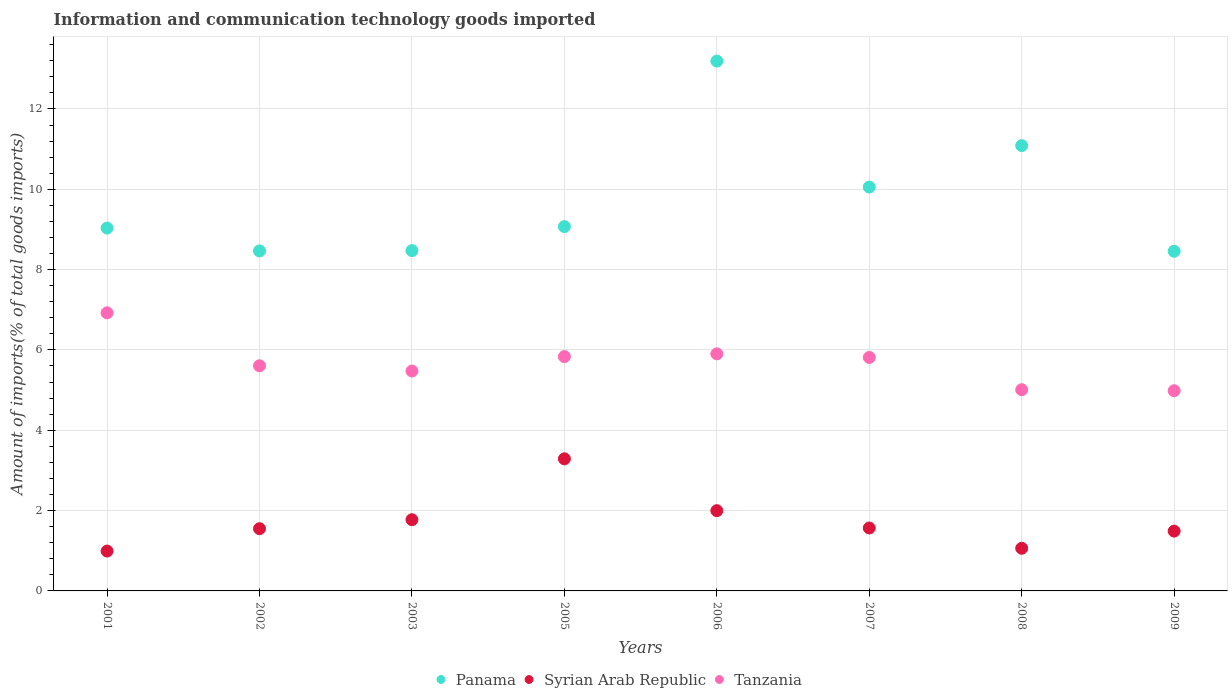How many different coloured dotlines are there?
Keep it short and to the point. 3. What is the amount of goods imported in Tanzania in 2002?
Provide a short and direct response. 5.6. Across all years, what is the maximum amount of goods imported in Syrian Arab Republic?
Offer a terse response. 3.29. Across all years, what is the minimum amount of goods imported in Panama?
Give a very brief answer. 8.46. In which year was the amount of goods imported in Tanzania minimum?
Ensure brevity in your answer.  2009. What is the total amount of goods imported in Tanzania in the graph?
Provide a succinct answer. 45.55. What is the difference between the amount of goods imported in Syrian Arab Republic in 2002 and that in 2006?
Offer a very short reply. -0.45. What is the difference between the amount of goods imported in Panama in 2001 and the amount of goods imported in Tanzania in 2008?
Your answer should be very brief. 4.02. What is the average amount of goods imported in Panama per year?
Make the answer very short. 9.73. In the year 2005, what is the difference between the amount of goods imported in Tanzania and amount of goods imported in Panama?
Your response must be concise. -3.24. What is the ratio of the amount of goods imported in Tanzania in 2003 to that in 2006?
Your answer should be very brief. 0.93. Is the amount of goods imported in Syrian Arab Republic in 2001 less than that in 2007?
Your response must be concise. Yes. Is the difference between the amount of goods imported in Tanzania in 2001 and 2006 greater than the difference between the amount of goods imported in Panama in 2001 and 2006?
Ensure brevity in your answer.  Yes. What is the difference between the highest and the second highest amount of goods imported in Panama?
Make the answer very short. 2.11. What is the difference between the highest and the lowest amount of goods imported in Syrian Arab Republic?
Ensure brevity in your answer.  2.3. In how many years, is the amount of goods imported in Panama greater than the average amount of goods imported in Panama taken over all years?
Provide a short and direct response. 3. Is the sum of the amount of goods imported in Tanzania in 2002 and 2008 greater than the maximum amount of goods imported in Syrian Arab Republic across all years?
Provide a succinct answer. Yes. Is it the case that in every year, the sum of the amount of goods imported in Syrian Arab Republic and amount of goods imported in Tanzania  is greater than the amount of goods imported in Panama?
Your response must be concise. No. Is the amount of goods imported in Tanzania strictly greater than the amount of goods imported in Panama over the years?
Provide a short and direct response. No. How many years are there in the graph?
Provide a succinct answer. 8. What is the difference between two consecutive major ticks on the Y-axis?
Provide a short and direct response. 2. Does the graph contain grids?
Offer a very short reply. Yes. How many legend labels are there?
Give a very brief answer. 3. How are the legend labels stacked?
Make the answer very short. Horizontal. What is the title of the graph?
Offer a terse response. Information and communication technology goods imported. Does "Marshall Islands" appear as one of the legend labels in the graph?
Provide a short and direct response. No. What is the label or title of the Y-axis?
Give a very brief answer. Amount of imports(% of total goods imports). What is the Amount of imports(% of total goods imports) of Panama in 2001?
Make the answer very short. 9.03. What is the Amount of imports(% of total goods imports) in Syrian Arab Republic in 2001?
Your answer should be very brief. 0.99. What is the Amount of imports(% of total goods imports) in Tanzania in 2001?
Your answer should be compact. 6.92. What is the Amount of imports(% of total goods imports) in Panama in 2002?
Provide a succinct answer. 8.46. What is the Amount of imports(% of total goods imports) in Syrian Arab Republic in 2002?
Give a very brief answer. 1.55. What is the Amount of imports(% of total goods imports) of Tanzania in 2002?
Offer a terse response. 5.6. What is the Amount of imports(% of total goods imports) of Panama in 2003?
Ensure brevity in your answer.  8.47. What is the Amount of imports(% of total goods imports) in Syrian Arab Republic in 2003?
Ensure brevity in your answer.  1.77. What is the Amount of imports(% of total goods imports) of Tanzania in 2003?
Your answer should be compact. 5.47. What is the Amount of imports(% of total goods imports) of Panama in 2005?
Your answer should be compact. 9.07. What is the Amount of imports(% of total goods imports) of Syrian Arab Republic in 2005?
Give a very brief answer. 3.29. What is the Amount of imports(% of total goods imports) of Tanzania in 2005?
Provide a succinct answer. 5.83. What is the Amount of imports(% of total goods imports) in Panama in 2006?
Ensure brevity in your answer.  13.19. What is the Amount of imports(% of total goods imports) in Syrian Arab Republic in 2006?
Keep it short and to the point. 2. What is the Amount of imports(% of total goods imports) in Tanzania in 2006?
Your answer should be compact. 5.9. What is the Amount of imports(% of total goods imports) of Panama in 2007?
Offer a terse response. 10.06. What is the Amount of imports(% of total goods imports) in Syrian Arab Republic in 2007?
Provide a succinct answer. 1.57. What is the Amount of imports(% of total goods imports) in Tanzania in 2007?
Keep it short and to the point. 5.81. What is the Amount of imports(% of total goods imports) of Panama in 2008?
Your answer should be very brief. 11.09. What is the Amount of imports(% of total goods imports) in Syrian Arab Republic in 2008?
Give a very brief answer. 1.06. What is the Amount of imports(% of total goods imports) in Tanzania in 2008?
Ensure brevity in your answer.  5.01. What is the Amount of imports(% of total goods imports) in Panama in 2009?
Provide a succinct answer. 8.46. What is the Amount of imports(% of total goods imports) in Syrian Arab Republic in 2009?
Give a very brief answer. 1.49. What is the Amount of imports(% of total goods imports) in Tanzania in 2009?
Give a very brief answer. 4.98. Across all years, what is the maximum Amount of imports(% of total goods imports) of Panama?
Make the answer very short. 13.19. Across all years, what is the maximum Amount of imports(% of total goods imports) of Syrian Arab Republic?
Your response must be concise. 3.29. Across all years, what is the maximum Amount of imports(% of total goods imports) in Tanzania?
Ensure brevity in your answer.  6.92. Across all years, what is the minimum Amount of imports(% of total goods imports) of Panama?
Provide a succinct answer. 8.46. Across all years, what is the minimum Amount of imports(% of total goods imports) of Syrian Arab Republic?
Your answer should be very brief. 0.99. Across all years, what is the minimum Amount of imports(% of total goods imports) of Tanzania?
Your answer should be very brief. 4.98. What is the total Amount of imports(% of total goods imports) of Panama in the graph?
Your response must be concise. 77.83. What is the total Amount of imports(% of total goods imports) in Syrian Arab Republic in the graph?
Give a very brief answer. 13.72. What is the total Amount of imports(% of total goods imports) of Tanzania in the graph?
Offer a terse response. 45.55. What is the difference between the Amount of imports(% of total goods imports) of Panama in 2001 and that in 2002?
Your answer should be very brief. 0.57. What is the difference between the Amount of imports(% of total goods imports) of Syrian Arab Republic in 2001 and that in 2002?
Ensure brevity in your answer.  -0.56. What is the difference between the Amount of imports(% of total goods imports) in Tanzania in 2001 and that in 2002?
Offer a very short reply. 1.32. What is the difference between the Amount of imports(% of total goods imports) of Panama in 2001 and that in 2003?
Your answer should be compact. 0.56. What is the difference between the Amount of imports(% of total goods imports) of Syrian Arab Republic in 2001 and that in 2003?
Keep it short and to the point. -0.78. What is the difference between the Amount of imports(% of total goods imports) of Tanzania in 2001 and that in 2003?
Ensure brevity in your answer.  1.45. What is the difference between the Amount of imports(% of total goods imports) in Panama in 2001 and that in 2005?
Provide a short and direct response. -0.04. What is the difference between the Amount of imports(% of total goods imports) of Syrian Arab Republic in 2001 and that in 2005?
Ensure brevity in your answer.  -2.3. What is the difference between the Amount of imports(% of total goods imports) of Tanzania in 2001 and that in 2005?
Your answer should be very brief. 1.09. What is the difference between the Amount of imports(% of total goods imports) in Panama in 2001 and that in 2006?
Offer a terse response. -4.16. What is the difference between the Amount of imports(% of total goods imports) in Syrian Arab Republic in 2001 and that in 2006?
Your response must be concise. -1.01. What is the difference between the Amount of imports(% of total goods imports) in Tanzania in 2001 and that in 2006?
Your answer should be very brief. 1.02. What is the difference between the Amount of imports(% of total goods imports) in Panama in 2001 and that in 2007?
Ensure brevity in your answer.  -1.02. What is the difference between the Amount of imports(% of total goods imports) of Syrian Arab Republic in 2001 and that in 2007?
Keep it short and to the point. -0.57. What is the difference between the Amount of imports(% of total goods imports) of Tanzania in 2001 and that in 2007?
Your answer should be very brief. 1.11. What is the difference between the Amount of imports(% of total goods imports) of Panama in 2001 and that in 2008?
Your response must be concise. -2.05. What is the difference between the Amount of imports(% of total goods imports) of Syrian Arab Republic in 2001 and that in 2008?
Make the answer very short. -0.07. What is the difference between the Amount of imports(% of total goods imports) in Tanzania in 2001 and that in 2008?
Your answer should be compact. 1.91. What is the difference between the Amount of imports(% of total goods imports) in Panama in 2001 and that in 2009?
Give a very brief answer. 0.58. What is the difference between the Amount of imports(% of total goods imports) in Syrian Arab Republic in 2001 and that in 2009?
Your answer should be very brief. -0.5. What is the difference between the Amount of imports(% of total goods imports) of Tanzania in 2001 and that in 2009?
Provide a short and direct response. 1.94. What is the difference between the Amount of imports(% of total goods imports) in Panama in 2002 and that in 2003?
Offer a terse response. -0.01. What is the difference between the Amount of imports(% of total goods imports) in Syrian Arab Republic in 2002 and that in 2003?
Ensure brevity in your answer.  -0.22. What is the difference between the Amount of imports(% of total goods imports) in Tanzania in 2002 and that in 2003?
Offer a very short reply. 0.13. What is the difference between the Amount of imports(% of total goods imports) of Panama in 2002 and that in 2005?
Give a very brief answer. -0.61. What is the difference between the Amount of imports(% of total goods imports) of Syrian Arab Republic in 2002 and that in 2005?
Give a very brief answer. -1.74. What is the difference between the Amount of imports(% of total goods imports) of Tanzania in 2002 and that in 2005?
Provide a short and direct response. -0.23. What is the difference between the Amount of imports(% of total goods imports) in Panama in 2002 and that in 2006?
Provide a short and direct response. -4.73. What is the difference between the Amount of imports(% of total goods imports) of Syrian Arab Republic in 2002 and that in 2006?
Provide a short and direct response. -0.45. What is the difference between the Amount of imports(% of total goods imports) in Tanzania in 2002 and that in 2006?
Ensure brevity in your answer.  -0.3. What is the difference between the Amount of imports(% of total goods imports) in Panama in 2002 and that in 2007?
Offer a very short reply. -1.59. What is the difference between the Amount of imports(% of total goods imports) in Syrian Arab Republic in 2002 and that in 2007?
Provide a short and direct response. -0.02. What is the difference between the Amount of imports(% of total goods imports) of Tanzania in 2002 and that in 2007?
Give a very brief answer. -0.21. What is the difference between the Amount of imports(% of total goods imports) of Panama in 2002 and that in 2008?
Keep it short and to the point. -2.62. What is the difference between the Amount of imports(% of total goods imports) in Syrian Arab Republic in 2002 and that in 2008?
Ensure brevity in your answer.  0.49. What is the difference between the Amount of imports(% of total goods imports) of Tanzania in 2002 and that in 2008?
Keep it short and to the point. 0.6. What is the difference between the Amount of imports(% of total goods imports) in Panama in 2002 and that in 2009?
Make the answer very short. 0.01. What is the difference between the Amount of imports(% of total goods imports) of Syrian Arab Republic in 2002 and that in 2009?
Offer a terse response. 0.06. What is the difference between the Amount of imports(% of total goods imports) of Tanzania in 2002 and that in 2009?
Offer a very short reply. 0.62. What is the difference between the Amount of imports(% of total goods imports) in Panama in 2003 and that in 2005?
Your response must be concise. -0.6. What is the difference between the Amount of imports(% of total goods imports) in Syrian Arab Republic in 2003 and that in 2005?
Your answer should be compact. -1.52. What is the difference between the Amount of imports(% of total goods imports) of Tanzania in 2003 and that in 2005?
Give a very brief answer. -0.36. What is the difference between the Amount of imports(% of total goods imports) of Panama in 2003 and that in 2006?
Your response must be concise. -4.72. What is the difference between the Amount of imports(% of total goods imports) of Syrian Arab Republic in 2003 and that in 2006?
Ensure brevity in your answer.  -0.22. What is the difference between the Amount of imports(% of total goods imports) in Tanzania in 2003 and that in 2006?
Provide a short and direct response. -0.43. What is the difference between the Amount of imports(% of total goods imports) of Panama in 2003 and that in 2007?
Your answer should be compact. -1.58. What is the difference between the Amount of imports(% of total goods imports) of Syrian Arab Republic in 2003 and that in 2007?
Your answer should be compact. 0.21. What is the difference between the Amount of imports(% of total goods imports) in Tanzania in 2003 and that in 2007?
Give a very brief answer. -0.34. What is the difference between the Amount of imports(% of total goods imports) in Panama in 2003 and that in 2008?
Your answer should be compact. -2.61. What is the difference between the Amount of imports(% of total goods imports) of Syrian Arab Republic in 2003 and that in 2008?
Give a very brief answer. 0.71. What is the difference between the Amount of imports(% of total goods imports) of Tanzania in 2003 and that in 2008?
Offer a very short reply. 0.47. What is the difference between the Amount of imports(% of total goods imports) of Panama in 2003 and that in 2009?
Ensure brevity in your answer.  0.02. What is the difference between the Amount of imports(% of total goods imports) in Syrian Arab Republic in 2003 and that in 2009?
Keep it short and to the point. 0.28. What is the difference between the Amount of imports(% of total goods imports) in Tanzania in 2003 and that in 2009?
Make the answer very short. 0.49. What is the difference between the Amount of imports(% of total goods imports) in Panama in 2005 and that in 2006?
Your answer should be very brief. -4.12. What is the difference between the Amount of imports(% of total goods imports) in Syrian Arab Republic in 2005 and that in 2006?
Offer a terse response. 1.29. What is the difference between the Amount of imports(% of total goods imports) in Tanzania in 2005 and that in 2006?
Provide a short and direct response. -0.07. What is the difference between the Amount of imports(% of total goods imports) in Panama in 2005 and that in 2007?
Offer a terse response. -0.98. What is the difference between the Amount of imports(% of total goods imports) of Syrian Arab Republic in 2005 and that in 2007?
Provide a short and direct response. 1.72. What is the difference between the Amount of imports(% of total goods imports) of Tanzania in 2005 and that in 2007?
Make the answer very short. 0.02. What is the difference between the Amount of imports(% of total goods imports) of Panama in 2005 and that in 2008?
Offer a very short reply. -2.02. What is the difference between the Amount of imports(% of total goods imports) of Syrian Arab Republic in 2005 and that in 2008?
Keep it short and to the point. 2.23. What is the difference between the Amount of imports(% of total goods imports) of Tanzania in 2005 and that in 2008?
Ensure brevity in your answer.  0.82. What is the difference between the Amount of imports(% of total goods imports) in Panama in 2005 and that in 2009?
Your answer should be very brief. 0.61. What is the difference between the Amount of imports(% of total goods imports) in Syrian Arab Republic in 2005 and that in 2009?
Offer a very short reply. 1.8. What is the difference between the Amount of imports(% of total goods imports) in Tanzania in 2005 and that in 2009?
Your answer should be very brief. 0.85. What is the difference between the Amount of imports(% of total goods imports) in Panama in 2006 and that in 2007?
Your answer should be very brief. 3.14. What is the difference between the Amount of imports(% of total goods imports) of Syrian Arab Republic in 2006 and that in 2007?
Your answer should be compact. 0.43. What is the difference between the Amount of imports(% of total goods imports) in Tanzania in 2006 and that in 2007?
Make the answer very short. 0.09. What is the difference between the Amount of imports(% of total goods imports) of Panama in 2006 and that in 2008?
Provide a succinct answer. 2.1. What is the difference between the Amount of imports(% of total goods imports) of Syrian Arab Republic in 2006 and that in 2008?
Your answer should be very brief. 0.94. What is the difference between the Amount of imports(% of total goods imports) in Tanzania in 2006 and that in 2008?
Your answer should be very brief. 0.89. What is the difference between the Amount of imports(% of total goods imports) in Panama in 2006 and that in 2009?
Make the answer very short. 4.74. What is the difference between the Amount of imports(% of total goods imports) in Syrian Arab Republic in 2006 and that in 2009?
Give a very brief answer. 0.51. What is the difference between the Amount of imports(% of total goods imports) of Tanzania in 2006 and that in 2009?
Provide a short and direct response. 0.92. What is the difference between the Amount of imports(% of total goods imports) in Panama in 2007 and that in 2008?
Provide a succinct answer. -1.03. What is the difference between the Amount of imports(% of total goods imports) in Syrian Arab Republic in 2007 and that in 2008?
Your answer should be very brief. 0.5. What is the difference between the Amount of imports(% of total goods imports) in Tanzania in 2007 and that in 2008?
Your answer should be compact. 0.8. What is the difference between the Amount of imports(% of total goods imports) of Panama in 2007 and that in 2009?
Your answer should be very brief. 1.6. What is the difference between the Amount of imports(% of total goods imports) in Syrian Arab Republic in 2007 and that in 2009?
Offer a terse response. 0.08. What is the difference between the Amount of imports(% of total goods imports) in Tanzania in 2007 and that in 2009?
Ensure brevity in your answer.  0.83. What is the difference between the Amount of imports(% of total goods imports) of Panama in 2008 and that in 2009?
Provide a succinct answer. 2.63. What is the difference between the Amount of imports(% of total goods imports) in Syrian Arab Republic in 2008 and that in 2009?
Provide a succinct answer. -0.43. What is the difference between the Amount of imports(% of total goods imports) of Tanzania in 2008 and that in 2009?
Make the answer very short. 0.03. What is the difference between the Amount of imports(% of total goods imports) of Panama in 2001 and the Amount of imports(% of total goods imports) of Syrian Arab Republic in 2002?
Make the answer very short. 7.48. What is the difference between the Amount of imports(% of total goods imports) in Panama in 2001 and the Amount of imports(% of total goods imports) in Tanzania in 2002?
Ensure brevity in your answer.  3.43. What is the difference between the Amount of imports(% of total goods imports) in Syrian Arab Republic in 2001 and the Amount of imports(% of total goods imports) in Tanzania in 2002?
Offer a very short reply. -4.61. What is the difference between the Amount of imports(% of total goods imports) of Panama in 2001 and the Amount of imports(% of total goods imports) of Syrian Arab Republic in 2003?
Provide a succinct answer. 7.26. What is the difference between the Amount of imports(% of total goods imports) of Panama in 2001 and the Amount of imports(% of total goods imports) of Tanzania in 2003?
Offer a terse response. 3.56. What is the difference between the Amount of imports(% of total goods imports) in Syrian Arab Republic in 2001 and the Amount of imports(% of total goods imports) in Tanzania in 2003?
Your answer should be very brief. -4.48. What is the difference between the Amount of imports(% of total goods imports) in Panama in 2001 and the Amount of imports(% of total goods imports) in Syrian Arab Republic in 2005?
Provide a succinct answer. 5.74. What is the difference between the Amount of imports(% of total goods imports) of Panama in 2001 and the Amount of imports(% of total goods imports) of Tanzania in 2005?
Your answer should be compact. 3.2. What is the difference between the Amount of imports(% of total goods imports) in Syrian Arab Republic in 2001 and the Amount of imports(% of total goods imports) in Tanzania in 2005?
Provide a short and direct response. -4.84. What is the difference between the Amount of imports(% of total goods imports) in Panama in 2001 and the Amount of imports(% of total goods imports) in Syrian Arab Republic in 2006?
Provide a succinct answer. 7.04. What is the difference between the Amount of imports(% of total goods imports) in Panama in 2001 and the Amount of imports(% of total goods imports) in Tanzania in 2006?
Offer a terse response. 3.13. What is the difference between the Amount of imports(% of total goods imports) of Syrian Arab Republic in 2001 and the Amount of imports(% of total goods imports) of Tanzania in 2006?
Offer a terse response. -4.91. What is the difference between the Amount of imports(% of total goods imports) of Panama in 2001 and the Amount of imports(% of total goods imports) of Syrian Arab Republic in 2007?
Your answer should be very brief. 7.47. What is the difference between the Amount of imports(% of total goods imports) of Panama in 2001 and the Amount of imports(% of total goods imports) of Tanzania in 2007?
Ensure brevity in your answer.  3.22. What is the difference between the Amount of imports(% of total goods imports) of Syrian Arab Republic in 2001 and the Amount of imports(% of total goods imports) of Tanzania in 2007?
Offer a very short reply. -4.82. What is the difference between the Amount of imports(% of total goods imports) in Panama in 2001 and the Amount of imports(% of total goods imports) in Syrian Arab Republic in 2008?
Offer a terse response. 7.97. What is the difference between the Amount of imports(% of total goods imports) of Panama in 2001 and the Amount of imports(% of total goods imports) of Tanzania in 2008?
Provide a succinct answer. 4.02. What is the difference between the Amount of imports(% of total goods imports) of Syrian Arab Republic in 2001 and the Amount of imports(% of total goods imports) of Tanzania in 2008?
Your answer should be compact. -4.02. What is the difference between the Amount of imports(% of total goods imports) of Panama in 2001 and the Amount of imports(% of total goods imports) of Syrian Arab Republic in 2009?
Provide a succinct answer. 7.54. What is the difference between the Amount of imports(% of total goods imports) in Panama in 2001 and the Amount of imports(% of total goods imports) in Tanzania in 2009?
Keep it short and to the point. 4.05. What is the difference between the Amount of imports(% of total goods imports) of Syrian Arab Republic in 2001 and the Amount of imports(% of total goods imports) of Tanzania in 2009?
Your answer should be very brief. -3.99. What is the difference between the Amount of imports(% of total goods imports) in Panama in 2002 and the Amount of imports(% of total goods imports) in Syrian Arab Republic in 2003?
Offer a terse response. 6.69. What is the difference between the Amount of imports(% of total goods imports) of Panama in 2002 and the Amount of imports(% of total goods imports) of Tanzania in 2003?
Provide a short and direct response. 2.99. What is the difference between the Amount of imports(% of total goods imports) in Syrian Arab Republic in 2002 and the Amount of imports(% of total goods imports) in Tanzania in 2003?
Offer a terse response. -3.93. What is the difference between the Amount of imports(% of total goods imports) of Panama in 2002 and the Amount of imports(% of total goods imports) of Syrian Arab Republic in 2005?
Keep it short and to the point. 5.18. What is the difference between the Amount of imports(% of total goods imports) in Panama in 2002 and the Amount of imports(% of total goods imports) in Tanzania in 2005?
Your response must be concise. 2.63. What is the difference between the Amount of imports(% of total goods imports) in Syrian Arab Republic in 2002 and the Amount of imports(% of total goods imports) in Tanzania in 2005?
Offer a terse response. -4.28. What is the difference between the Amount of imports(% of total goods imports) in Panama in 2002 and the Amount of imports(% of total goods imports) in Syrian Arab Republic in 2006?
Provide a succinct answer. 6.47. What is the difference between the Amount of imports(% of total goods imports) of Panama in 2002 and the Amount of imports(% of total goods imports) of Tanzania in 2006?
Provide a short and direct response. 2.56. What is the difference between the Amount of imports(% of total goods imports) in Syrian Arab Republic in 2002 and the Amount of imports(% of total goods imports) in Tanzania in 2006?
Provide a succinct answer. -4.35. What is the difference between the Amount of imports(% of total goods imports) of Panama in 2002 and the Amount of imports(% of total goods imports) of Syrian Arab Republic in 2007?
Your answer should be compact. 6.9. What is the difference between the Amount of imports(% of total goods imports) in Panama in 2002 and the Amount of imports(% of total goods imports) in Tanzania in 2007?
Offer a very short reply. 2.65. What is the difference between the Amount of imports(% of total goods imports) in Syrian Arab Republic in 2002 and the Amount of imports(% of total goods imports) in Tanzania in 2007?
Provide a succinct answer. -4.26. What is the difference between the Amount of imports(% of total goods imports) in Panama in 2002 and the Amount of imports(% of total goods imports) in Syrian Arab Republic in 2008?
Offer a very short reply. 7.4. What is the difference between the Amount of imports(% of total goods imports) of Panama in 2002 and the Amount of imports(% of total goods imports) of Tanzania in 2008?
Provide a short and direct response. 3.45. What is the difference between the Amount of imports(% of total goods imports) in Syrian Arab Republic in 2002 and the Amount of imports(% of total goods imports) in Tanzania in 2008?
Ensure brevity in your answer.  -3.46. What is the difference between the Amount of imports(% of total goods imports) of Panama in 2002 and the Amount of imports(% of total goods imports) of Syrian Arab Republic in 2009?
Ensure brevity in your answer.  6.98. What is the difference between the Amount of imports(% of total goods imports) in Panama in 2002 and the Amount of imports(% of total goods imports) in Tanzania in 2009?
Your answer should be very brief. 3.48. What is the difference between the Amount of imports(% of total goods imports) in Syrian Arab Republic in 2002 and the Amount of imports(% of total goods imports) in Tanzania in 2009?
Make the answer very short. -3.43. What is the difference between the Amount of imports(% of total goods imports) of Panama in 2003 and the Amount of imports(% of total goods imports) of Syrian Arab Republic in 2005?
Provide a succinct answer. 5.18. What is the difference between the Amount of imports(% of total goods imports) in Panama in 2003 and the Amount of imports(% of total goods imports) in Tanzania in 2005?
Ensure brevity in your answer.  2.64. What is the difference between the Amount of imports(% of total goods imports) of Syrian Arab Republic in 2003 and the Amount of imports(% of total goods imports) of Tanzania in 2005?
Your answer should be compact. -4.06. What is the difference between the Amount of imports(% of total goods imports) in Panama in 2003 and the Amount of imports(% of total goods imports) in Syrian Arab Republic in 2006?
Give a very brief answer. 6.47. What is the difference between the Amount of imports(% of total goods imports) of Panama in 2003 and the Amount of imports(% of total goods imports) of Tanzania in 2006?
Keep it short and to the point. 2.57. What is the difference between the Amount of imports(% of total goods imports) of Syrian Arab Republic in 2003 and the Amount of imports(% of total goods imports) of Tanzania in 2006?
Ensure brevity in your answer.  -4.13. What is the difference between the Amount of imports(% of total goods imports) in Panama in 2003 and the Amount of imports(% of total goods imports) in Syrian Arab Republic in 2007?
Keep it short and to the point. 6.91. What is the difference between the Amount of imports(% of total goods imports) in Panama in 2003 and the Amount of imports(% of total goods imports) in Tanzania in 2007?
Keep it short and to the point. 2.66. What is the difference between the Amount of imports(% of total goods imports) in Syrian Arab Republic in 2003 and the Amount of imports(% of total goods imports) in Tanzania in 2007?
Your answer should be compact. -4.04. What is the difference between the Amount of imports(% of total goods imports) of Panama in 2003 and the Amount of imports(% of total goods imports) of Syrian Arab Republic in 2008?
Keep it short and to the point. 7.41. What is the difference between the Amount of imports(% of total goods imports) of Panama in 2003 and the Amount of imports(% of total goods imports) of Tanzania in 2008?
Ensure brevity in your answer.  3.46. What is the difference between the Amount of imports(% of total goods imports) of Syrian Arab Republic in 2003 and the Amount of imports(% of total goods imports) of Tanzania in 2008?
Ensure brevity in your answer.  -3.24. What is the difference between the Amount of imports(% of total goods imports) in Panama in 2003 and the Amount of imports(% of total goods imports) in Syrian Arab Republic in 2009?
Give a very brief answer. 6.98. What is the difference between the Amount of imports(% of total goods imports) of Panama in 2003 and the Amount of imports(% of total goods imports) of Tanzania in 2009?
Ensure brevity in your answer.  3.49. What is the difference between the Amount of imports(% of total goods imports) of Syrian Arab Republic in 2003 and the Amount of imports(% of total goods imports) of Tanzania in 2009?
Give a very brief answer. -3.21. What is the difference between the Amount of imports(% of total goods imports) in Panama in 2005 and the Amount of imports(% of total goods imports) in Syrian Arab Republic in 2006?
Offer a very short reply. 7.07. What is the difference between the Amount of imports(% of total goods imports) in Panama in 2005 and the Amount of imports(% of total goods imports) in Tanzania in 2006?
Offer a terse response. 3.17. What is the difference between the Amount of imports(% of total goods imports) in Syrian Arab Republic in 2005 and the Amount of imports(% of total goods imports) in Tanzania in 2006?
Offer a very short reply. -2.61. What is the difference between the Amount of imports(% of total goods imports) of Panama in 2005 and the Amount of imports(% of total goods imports) of Syrian Arab Republic in 2007?
Make the answer very short. 7.5. What is the difference between the Amount of imports(% of total goods imports) of Panama in 2005 and the Amount of imports(% of total goods imports) of Tanzania in 2007?
Offer a very short reply. 3.26. What is the difference between the Amount of imports(% of total goods imports) in Syrian Arab Republic in 2005 and the Amount of imports(% of total goods imports) in Tanzania in 2007?
Offer a terse response. -2.52. What is the difference between the Amount of imports(% of total goods imports) in Panama in 2005 and the Amount of imports(% of total goods imports) in Syrian Arab Republic in 2008?
Your response must be concise. 8.01. What is the difference between the Amount of imports(% of total goods imports) in Panama in 2005 and the Amount of imports(% of total goods imports) in Tanzania in 2008?
Make the answer very short. 4.06. What is the difference between the Amount of imports(% of total goods imports) of Syrian Arab Republic in 2005 and the Amount of imports(% of total goods imports) of Tanzania in 2008?
Offer a terse response. -1.72. What is the difference between the Amount of imports(% of total goods imports) of Panama in 2005 and the Amount of imports(% of total goods imports) of Syrian Arab Republic in 2009?
Offer a very short reply. 7.58. What is the difference between the Amount of imports(% of total goods imports) in Panama in 2005 and the Amount of imports(% of total goods imports) in Tanzania in 2009?
Your response must be concise. 4.09. What is the difference between the Amount of imports(% of total goods imports) of Syrian Arab Republic in 2005 and the Amount of imports(% of total goods imports) of Tanzania in 2009?
Keep it short and to the point. -1.7. What is the difference between the Amount of imports(% of total goods imports) of Panama in 2006 and the Amount of imports(% of total goods imports) of Syrian Arab Republic in 2007?
Ensure brevity in your answer.  11.62. What is the difference between the Amount of imports(% of total goods imports) of Panama in 2006 and the Amount of imports(% of total goods imports) of Tanzania in 2007?
Offer a terse response. 7.38. What is the difference between the Amount of imports(% of total goods imports) of Syrian Arab Republic in 2006 and the Amount of imports(% of total goods imports) of Tanzania in 2007?
Ensure brevity in your answer.  -3.82. What is the difference between the Amount of imports(% of total goods imports) of Panama in 2006 and the Amount of imports(% of total goods imports) of Syrian Arab Republic in 2008?
Give a very brief answer. 12.13. What is the difference between the Amount of imports(% of total goods imports) of Panama in 2006 and the Amount of imports(% of total goods imports) of Tanzania in 2008?
Offer a terse response. 8.18. What is the difference between the Amount of imports(% of total goods imports) of Syrian Arab Republic in 2006 and the Amount of imports(% of total goods imports) of Tanzania in 2008?
Provide a short and direct response. -3.01. What is the difference between the Amount of imports(% of total goods imports) of Panama in 2006 and the Amount of imports(% of total goods imports) of Syrian Arab Republic in 2009?
Offer a terse response. 11.7. What is the difference between the Amount of imports(% of total goods imports) of Panama in 2006 and the Amount of imports(% of total goods imports) of Tanzania in 2009?
Offer a very short reply. 8.21. What is the difference between the Amount of imports(% of total goods imports) of Syrian Arab Republic in 2006 and the Amount of imports(% of total goods imports) of Tanzania in 2009?
Make the answer very short. -2.99. What is the difference between the Amount of imports(% of total goods imports) in Panama in 2007 and the Amount of imports(% of total goods imports) in Syrian Arab Republic in 2008?
Ensure brevity in your answer.  8.99. What is the difference between the Amount of imports(% of total goods imports) in Panama in 2007 and the Amount of imports(% of total goods imports) in Tanzania in 2008?
Make the answer very short. 5.05. What is the difference between the Amount of imports(% of total goods imports) in Syrian Arab Republic in 2007 and the Amount of imports(% of total goods imports) in Tanzania in 2008?
Keep it short and to the point. -3.44. What is the difference between the Amount of imports(% of total goods imports) in Panama in 2007 and the Amount of imports(% of total goods imports) in Syrian Arab Republic in 2009?
Your answer should be compact. 8.57. What is the difference between the Amount of imports(% of total goods imports) of Panama in 2007 and the Amount of imports(% of total goods imports) of Tanzania in 2009?
Offer a very short reply. 5.07. What is the difference between the Amount of imports(% of total goods imports) of Syrian Arab Republic in 2007 and the Amount of imports(% of total goods imports) of Tanzania in 2009?
Your answer should be very brief. -3.42. What is the difference between the Amount of imports(% of total goods imports) in Panama in 2008 and the Amount of imports(% of total goods imports) in Syrian Arab Republic in 2009?
Ensure brevity in your answer.  9.6. What is the difference between the Amount of imports(% of total goods imports) of Panama in 2008 and the Amount of imports(% of total goods imports) of Tanzania in 2009?
Keep it short and to the point. 6.1. What is the difference between the Amount of imports(% of total goods imports) in Syrian Arab Republic in 2008 and the Amount of imports(% of total goods imports) in Tanzania in 2009?
Your answer should be compact. -3.92. What is the average Amount of imports(% of total goods imports) of Panama per year?
Offer a terse response. 9.73. What is the average Amount of imports(% of total goods imports) in Syrian Arab Republic per year?
Keep it short and to the point. 1.72. What is the average Amount of imports(% of total goods imports) of Tanzania per year?
Your answer should be compact. 5.69. In the year 2001, what is the difference between the Amount of imports(% of total goods imports) of Panama and Amount of imports(% of total goods imports) of Syrian Arab Republic?
Make the answer very short. 8.04. In the year 2001, what is the difference between the Amount of imports(% of total goods imports) in Panama and Amount of imports(% of total goods imports) in Tanzania?
Ensure brevity in your answer.  2.11. In the year 2001, what is the difference between the Amount of imports(% of total goods imports) of Syrian Arab Republic and Amount of imports(% of total goods imports) of Tanzania?
Offer a terse response. -5.93. In the year 2002, what is the difference between the Amount of imports(% of total goods imports) of Panama and Amount of imports(% of total goods imports) of Syrian Arab Republic?
Provide a succinct answer. 6.91. In the year 2002, what is the difference between the Amount of imports(% of total goods imports) of Panama and Amount of imports(% of total goods imports) of Tanzania?
Offer a terse response. 2.86. In the year 2002, what is the difference between the Amount of imports(% of total goods imports) of Syrian Arab Republic and Amount of imports(% of total goods imports) of Tanzania?
Give a very brief answer. -4.05. In the year 2003, what is the difference between the Amount of imports(% of total goods imports) of Panama and Amount of imports(% of total goods imports) of Syrian Arab Republic?
Keep it short and to the point. 6.7. In the year 2003, what is the difference between the Amount of imports(% of total goods imports) in Panama and Amount of imports(% of total goods imports) in Tanzania?
Provide a succinct answer. 3. In the year 2003, what is the difference between the Amount of imports(% of total goods imports) in Syrian Arab Republic and Amount of imports(% of total goods imports) in Tanzania?
Provide a succinct answer. -3.7. In the year 2005, what is the difference between the Amount of imports(% of total goods imports) in Panama and Amount of imports(% of total goods imports) in Syrian Arab Republic?
Provide a short and direct response. 5.78. In the year 2005, what is the difference between the Amount of imports(% of total goods imports) of Panama and Amount of imports(% of total goods imports) of Tanzania?
Offer a terse response. 3.24. In the year 2005, what is the difference between the Amount of imports(% of total goods imports) of Syrian Arab Republic and Amount of imports(% of total goods imports) of Tanzania?
Keep it short and to the point. -2.54. In the year 2006, what is the difference between the Amount of imports(% of total goods imports) of Panama and Amount of imports(% of total goods imports) of Syrian Arab Republic?
Offer a very short reply. 11.19. In the year 2006, what is the difference between the Amount of imports(% of total goods imports) in Panama and Amount of imports(% of total goods imports) in Tanzania?
Your answer should be very brief. 7.29. In the year 2006, what is the difference between the Amount of imports(% of total goods imports) in Syrian Arab Republic and Amount of imports(% of total goods imports) in Tanzania?
Give a very brief answer. -3.9. In the year 2007, what is the difference between the Amount of imports(% of total goods imports) in Panama and Amount of imports(% of total goods imports) in Syrian Arab Republic?
Offer a terse response. 8.49. In the year 2007, what is the difference between the Amount of imports(% of total goods imports) of Panama and Amount of imports(% of total goods imports) of Tanzania?
Offer a terse response. 4.24. In the year 2007, what is the difference between the Amount of imports(% of total goods imports) of Syrian Arab Republic and Amount of imports(% of total goods imports) of Tanzania?
Your answer should be very brief. -4.25. In the year 2008, what is the difference between the Amount of imports(% of total goods imports) in Panama and Amount of imports(% of total goods imports) in Syrian Arab Republic?
Your answer should be very brief. 10.02. In the year 2008, what is the difference between the Amount of imports(% of total goods imports) in Panama and Amount of imports(% of total goods imports) in Tanzania?
Make the answer very short. 6.08. In the year 2008, what is the difference between the Amount of imports(% of total goods imports) of Syrian Arab Republic and Amount of imports(% of total goods imports) of Tanzania?
Your response must be concise. -3.95. In the year 2009, what is the difference between the Amount of imports(% of total goods imports) of Panama and Amount of imports(% of total goods imports) of Syrian Arab Republic?
Provide a short and direct response. 6.97. In the year 2009, what is the difference between the Amount of imports(% of total goods imports) in Panama and Amount of imports(% of total goods imports) in Tanzania?
Ensure brevity in your answer.  3.47. In the year 2009, what is the difference between the Amount of imports(% of total goods imports) in Syrian Arab Republic and Amount of imports(% of total goods imports) in Tanzania?
Ensure brevity in your answer.  -3.5. What is the ratio of the Amount of imports(% of total goods imports) of Panama in 2001 to that in 2002?
Give a very brief answer. 1.07. What is the ratio of the Amount of imports(% of total goods imports) of Syrian Arab Republic in 2001 to that in 2002?
Keep it short and to the point. 0.64. What is the ratio of the Amount of imports(% of total goods imports) of Tanzania in 2001 to that in 2002?
Provide a short and direct response. 1.24. What is the ratio of the Amount of imports(% of total goods imports) in Panama in 2001 to that in 2003?
Make the answer very short. 1.07. What is the ratio of the Amount of imports(% of total goods imports) in Syrian Arab Republic in 2001 to that in 2003?
Provide a succinct answer. 0.56. What is the ratio of the Amount of imports(% of total goods imports) in Tanzania in 2001 to that in 2003?
Give a very brief answer. 1.26. What is the ratio of the Amount of imports(% of total goods imports) of Syrian Arab Republic in 2001 to that in 2005?
Make the answer very short. 0.3. What is the ratio of the Amount of imports(% of total goods imports) of Tanzania in 2001 to that in 2005?
Ensure brevity in your answer.  1.19. What is the ratio of the Amount of imports(% of total goods imports) of Panama in 2001 to that in 2006?
Provide a short and direct response. 0.68. What is the ratio of the Amount of imports(% of total goods imports) of Syrian Arab Republic in 2001 to that in 2006?
Your answer should be compact. 0.5. What is the ratio of the Amount of imports(% of total goods imports) in Tanzania in 2001 to that in 2006?
Your answer should be compact. 1.17. What is the ratio of the Amount of imports(% of total goods imports) of Panama in 2001 to that in 2007?
Provide a succinct answer. 0.9. What is the ratio of the Amount of imports(% of total goods imports) in Syrian Arab Republic in 2001 to that in 2007?
Provide a short and direct response. 0.63. What is the ratio of the Amount of imports(% of total goods imports) of Tanzania in 2001 to that in 2007?
Provide a succinct answer. 1.19. What is the ratio of the Amount of imports(% of total goods imports) in Panama in 2001 to that in 2008?
Keep it short and to the point. 0.81. What is the ratio of the Amount of imports(% of total goods imports) in Syrian Arab Republic in 2001 to that in 2008?
Make the answer very short. 0.93. What is the ratio of the Amount of imports(% of total goods imports) of Tanzania in 2001 to that in 2008?
Your answer should be compact. 1.38. What is the ratio of the Amount of imports(% of total goods imports) in Panama in 2001 to that in 2009?
Your response must be concise. 1.07. What is the ratio of the Amount of imports(% of total goods imports) in Syrian Arab Republic in 2001 to that in 2009?
Provide a succinct answer. 0.67. What is the ratio of the Amount of imports(% of total goods imports) in Tanzania in 2001 to that in 2009?
Ensure brevity in your answer.  1.39. What is the ratio of the Amount of imports(% of total goods imports) in Panama in 2002 to that in 2003?
Provide a short and direct response. 1. What is the ratio of the Amount of imports(% of total goods imports) of Syrian Arab Republic in 2002 to that in 2003?
Your response must be concise. 0.87. What is the ratio of the Amount of imports(% of total goods imports) of Tanzania in 2002 to that in 2003?
Give a very brief answer. 1.02. What is the ratio of the Amount of imports(% of total goods imports) of Panama in 2002 to that in 2005?
Your answer should be compact. 0.93. What is the ratio of the Amount of imports(% of total goods imports) in Syrian Arab Republic in 2002 to that in 2005?
Provide a succinct answer. 0.47. What is the ratio of the Amount of imports(% of total goods imports) of Tanzania in 2002 to that in 2005?
Give a very brief answer. 0.96. What is the ratio of the Amount of imports(% of total goods imports) in Panama in 2002 to that in 2006?
Give a very brief answer. 0.64. What is the ratio of the Amount of imports(% of total goods imports) in Syrian Arab Republic in 2002 to that in 2006?
Your answer should be compact. 0.78. What is the ratio of the Amount of imports(% of total goods imports) of Tanzania in 2002 to that in 2006?
Provide a succinct answer. 0.95. What is the ratio of the Amount of imports(% of total goods imports) of Panama in 2002 to that in 2007?
Ensure brevity in your answer.  0.84. What is the ratio of the Amount of imports(% of total goods imports) in Syrian Arab Republic in 2002 to that in 2007?
Offer a terse response. 0.99. What is the ratio of the Amount of imports(% of total goods imports) in Tanzania in 2002 to that in 2007?
Ensure brevity in your answer.  0.96. What is the ratio of the Amount of imports(% of total goods imports) in Panama in 2002 to that in 2008?
Your response must be concise. 0.76. What is the ratio of the Amount of imports(% of total goods imports) in Syrian Arab Republic in 2002 to that in 2008?
Offer a terse response. 1.46. What is the ratio of the Amount of imports(% of total goods imports) in Tanzania in 2002 to that in 2008?
Your answer should be very brief. 1.12. What is the ratio of the Amount of imports(% of total goods imports) of Syrian Arab Republic in 2002 to that in 2009?
Make the answer very short. 1.04. What is the ratio of the Amount of imports(% of total goods imports) of Tanzania in 2002 to that in 2009?
Your answer should be compact. 1.12. What is the ratio of the Amount of imports(% of total goods imports) in Panama in 2003 to that in 2005?
Your answer should be compact. 0.93. What is the ratio of the Amount of imports(% of total goods imports) in Syrian Arab Republic in 2003 to that in 2005?
Offer a very short reply. 0.54. What is the ratio of the Amount of imports(% of total goods imports) in Tanzania in 2003 to that in 2005?
Ensure brevity in your answer.  0.94. What is the ratio of the Amount of imports(% of total goods imports) of Panama in 2003 to that in 2006?
Your answer should be very brief. 0.64. What is the ratio of the Amount of imports(% of total goods imports) of Syrian Arab Republic in 2003 to that in 2006?
Ensure brevity in your answer.  0.89. What is the ratio of the Amount of imports(% of total goods imports) of Tanzania in 2003 to that in 2006?
Keep it short and to the point. 0.93. What is the ratio of the Amount of imports(% of total goods imports) in Panama in 2003 to that in 2007?
Provide a succinct answer. 0.84. What is the ratio of the Amount of imports(% of total goods imports) in Syrian Arab Republic in 2003 to that in 2007?
Ensure brevity in your answer.  1.13. What is the ratio of the Amount of imports(% of total goods imports) of Tanzania in 2003 to that in 2007?
Give a very brief answer. 0.94. What is the ratio of the Amount of imports(% of total goods imports) of Panama in 2003 to that in 2008?
Your response must be concise. 0.76. What is the ratio of the Amount of imports(% of total goods imports) in Syrian Arab Republic in 2003 to that in 2008?
Ensure brevity in your answer.  1.67. What is the ratio of the Amount of imports(% of total goods imports) in Tanzania in 2003 to that in 2008?
Provide a short and direct response. 1.09. What is the ratio of the Amount of imports(% of total goods imports) in Syrian Arab Republic in 2003 to that in 2009?
Provide a succinct answer. 1.19. What is the ratio of the Amount of imports(% of total goods imports) of Tanzania in 2003 to that in 2009?
Keep it short and to the point. 1.1. What is the ratio of the Amount of imports(% of total goods imports) in Panama in 2005 to that in 2006?
Your answer should be very brief. 0.69. What is the ratio of the Amount of imports(% of total goods imports) in Syrian Arab Republic in 2005 to that in 2006?
Give a very brief answer. 1.65. What is the ratio of the Amount of imports(% of total goods imports) of Tanzania in 2005 to that in 2006?
Offer a terse response. 0.99. What is the ratio of the Amount of imports(% of total goods imports) of Panama in 2005 to that in 2007?
Ensure brevity in your answer.  0.9. What is the ratio of the Amount of imports(% of total goods imports) of Syrian Arab Republic in 2005 to that in 2007?
Give a very brief answer. 2.1. What is the ratio of the Amount of imports(% of total goods imports) of Tanzania in 2005 to that in 2007?
Offer a terse response. 1. What is the ratio of the Amount of imports(% of total goods imports) of Panama in 2005 to that in 2008?
Offer a very short reply. 0.82. What is the ratio of the Amount of imports(% of total goods imports) in Syrian Arab Republic in 2005 to that in 2008?
Make the answer very short. 3.1. What is the ratio of the Amount of imports(% of total goods imports) of Tanzania in 2005 to that in 2008?
Give a very brief answer. 1.16. What is the ratio of the Amount of imports(% of total goods imports) of Panama in 2005 to that in 2009?
Provide a short and direct response. 1.07. What is the ratio of the Amount of imports(% of total goods imports) of Syrian Arab Republic in 2005 to that in 2009?
Provide a short and direct response. 2.21. What is the ratio of the Amount of imports(% of total goods imports) of Tanzania in 2005 to that in 2009?
Make the answer very short. 1.17. What is the ratio of the Amount of imports(% of total goods imports) of Panama in 2006 to that in 2007?
Your answer should be very brief. 1.31. What is the ratio of the Amount of imports(% of total goods imports) in Syrian Arab Republic in 2006 to that in 2007?
Give a very brief answer. 1.28. What is the ratio of the Amount of imports(% of total goods imports) in Tanzania in 2006 to that in 2007?
Provide a short and direct response. 1.02. What is the ratio of the Amount of imports(% of total goods imports) in Panama in 2006 to that in 2008?
Offer a terse response. 1.19. What is the ratio of the Amount of imports(% of total goods imports) of Syrian Arab Republic in 2006 to that in 2008?
Keep it short and to the point. 1.88. What is the ratio of the Amount of imports(% of total goods imports) of Tanzania in 2006 to that in 2008?
Offer a very short reply. 1.18. What is the ratio of the Amount of imports(% of total goods imports) of Panama in 2006 to that in 2009?
Provide a short and direct response. 1.56. What is the ratio of the Amount of imports(% of total goods imports) of Syrian Arab Republic in 2006 to that in 2009?
Make the answer very short. 1.34. What is the ratio of the Amount of imports(% of total goods imports) of Tanzania in 2006 to that in 2009?
Offer a terse response. 1.18. What is the ratio of the Amount of imports(% of total goods imports) in Panama in 2007 to that in 2008?
Offer a very short reply. 0.91. What is the ratio of the Amount of imports(% of total goods imports) of Syrian Arab Republic in 2007 to that in 2008?
Ensure brevity in your answer.  1.48. What is the ratio of the Amount of imports(% of total goods imports) of Tanzania in 2007 to that in 2008?
Keep it short and to the point. 1.16. What is the ratio of the Amount of imports(% of total goods imports) of Panama in 2007 to that in 2009?
Your answer should be very brief. 1.19. What is the ratio of the Amount of imports(% of total goods imports) in Syrian Arab Republic in 2007 to that in 2009?
Provide a short and direct response. 1.05. What is the ratio of the Amount of imports(% of total goods imports) in Tanzania in 2007 to that in 2009?
Your answer should be very brief. 1.17. What is the ratio of the Amount of imports(% of total goods imports) in Panama in 2008 to that in 2009?
Give a very brief answer. 1.31. What is the ratio of the Amount of imports(% of total goods imports) in Syrian Arab Republic in 2008 to that in 2009?
Keep it short and to the point. 0.71. What is the difference between the highest and the second highest Amount of imports(% of total goods imports) in Panama?
Provide a short and direct response. 2.1. What is the difference between the highest and the second highest Amount of imports(% of total goods imports) of Syrian Arab Republic?
Give a very brief answer. 1.29. What is the difference between the highest and the second highest Amount of imports(% of total goods imports) of Tanzania?
Your response must be concise. 1.02. What is the difference between the highest and the lowest Amount of imports(% of total goods imports) of Panama?
Ensure brevity in your answer.  4.74. What is the difference between the highest and the lowest Amount of imports(% of total goods imports) in Syrian Arab Republic?
Your answer should be compact. 2.3. What is the difference between the highest and the lowest Amount of imports(% of total goods imports) of Tanzania?
Ensure brevity in your answer.  1.94. 